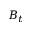Convert formula to latex. <formula><loc_0><loc_0><loc_500><loc_500>B _ { t }</formula> 